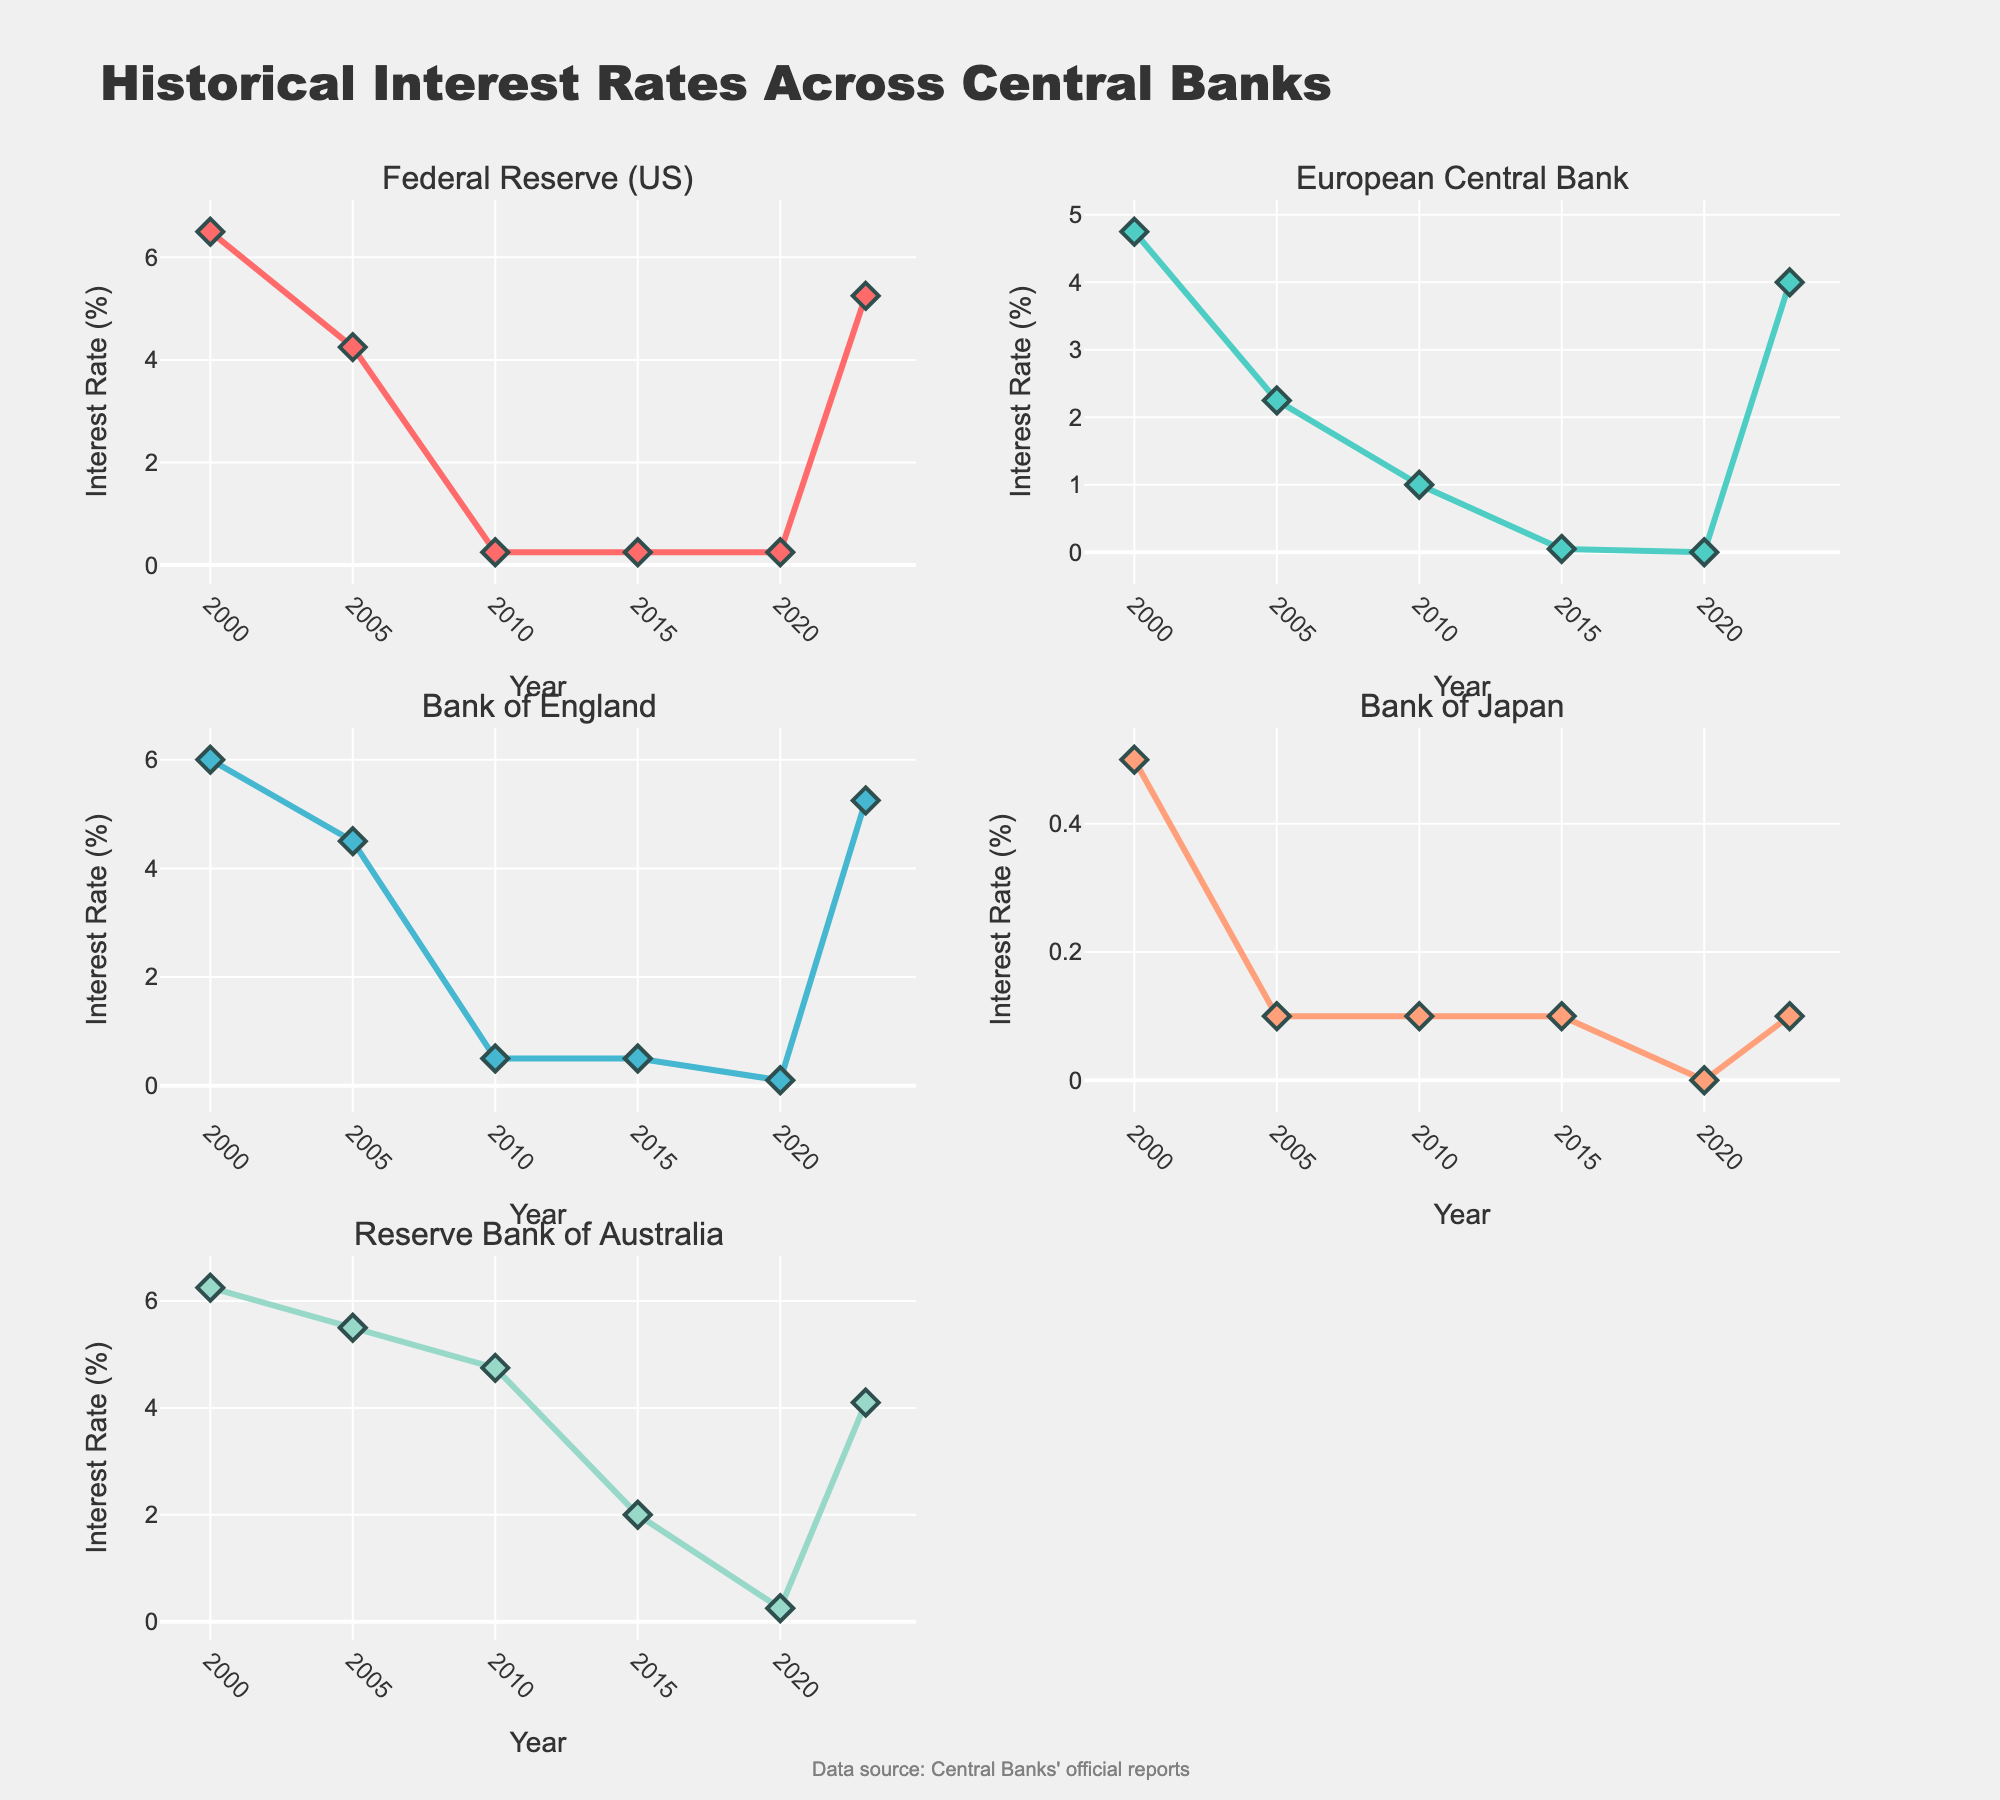How many destinations have higher visitor numbers in January compared to December? Bali and Dubai show higher visitor numbers in January than in December. Bali jumps from 190,000 to 150,000 visitors, and Dubai increases from 380,000 to 400,000 visitors.
Answer: 2 Which destination has the highest number of visitors in August? Looking at the subplot for August across all destinations, Paris has 520,000 visitors, the highest among the listed destinations.
Answer: Paris How does the number of visitors in Tokyo change from April to May? In Tokyo, visitors dip from 350,000 in April to 320,000 in May. The change can be calculated as 350,000 - 320,000 = 30,000 fewer visitors.
Answer: Decreases by 30,000 What is the average number of visitors in Santorini for the months of June, July, and August? Adding the visitor counts for June (180,000), July (220,000), and August (240,000) gives a total of 640,000. Dividing by 3 months, the average comes out to 640,000 / 3 = 213,333 visitors.
Answer: 213,333 Which destination exhibits a decreasing visitor trend from January to June? Analyzing each destination, Dubai shows a decreasing trend starting from 400,000 in January to 200,000 in June.
Answer: Dubai What is the difference in visitor numbers between the most popular and least popular destination in July? In July, Paris has the highest number with 500,000 visitors and Queenstown has the lowest with 130,000 visitors. Hence, the difference is 500,000 - 130,000 = 370,000 visitors.
Answer: 370,000 Between which consecutive months is the largest visitor increase for New York City? In New York City, the largest increase is from June to July, where visitors rise from 460,000 to 500,000, a difference of 40,000 visitors.
Answer: June to July Is there any destination where the number of visitors remains constant throughout a particular season? No destination shows a constant number of visitors throughout any season; each one has fluctuations in visitor numbers.
Answer: No Which destination has the most significant month-to-month fluctuation in visitor numbers throughout the year? By calculating differences between months for each destination, New York City exhibits significant fluctuations, noticeably in changes like from October to November (difference of 20,000). Thus, it has the largest overall volatility in visitors.
Answer: New York City 